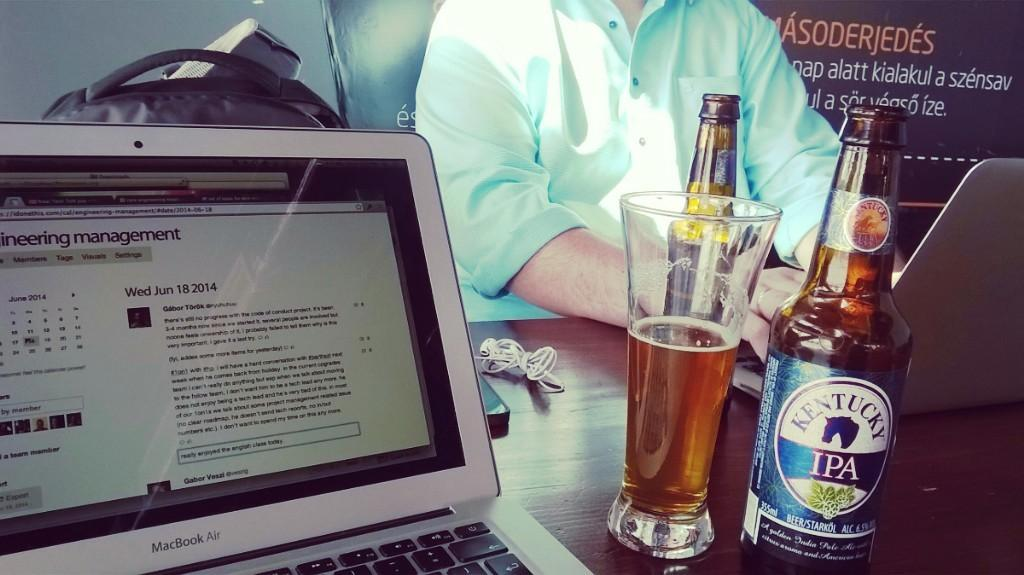<image>
Share a concise interpretation of the image provided. A bottle of Kentucky IPA is on a table with a glass and a MacBook Air laptop. 